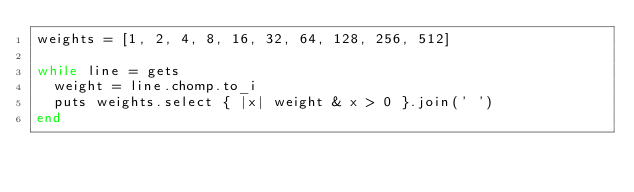Convert code to text. <code><loc_0><loc_0><loc_500><loc_500><_Ruby_>weights = [1, 2, 4, 8, 16, 32, 64, 128, 256, 512]

while line = gets
  weight = line.chomp.to_i
  puts weights.select { |x| weight & x > 0 }.join(' ')
end</code> 